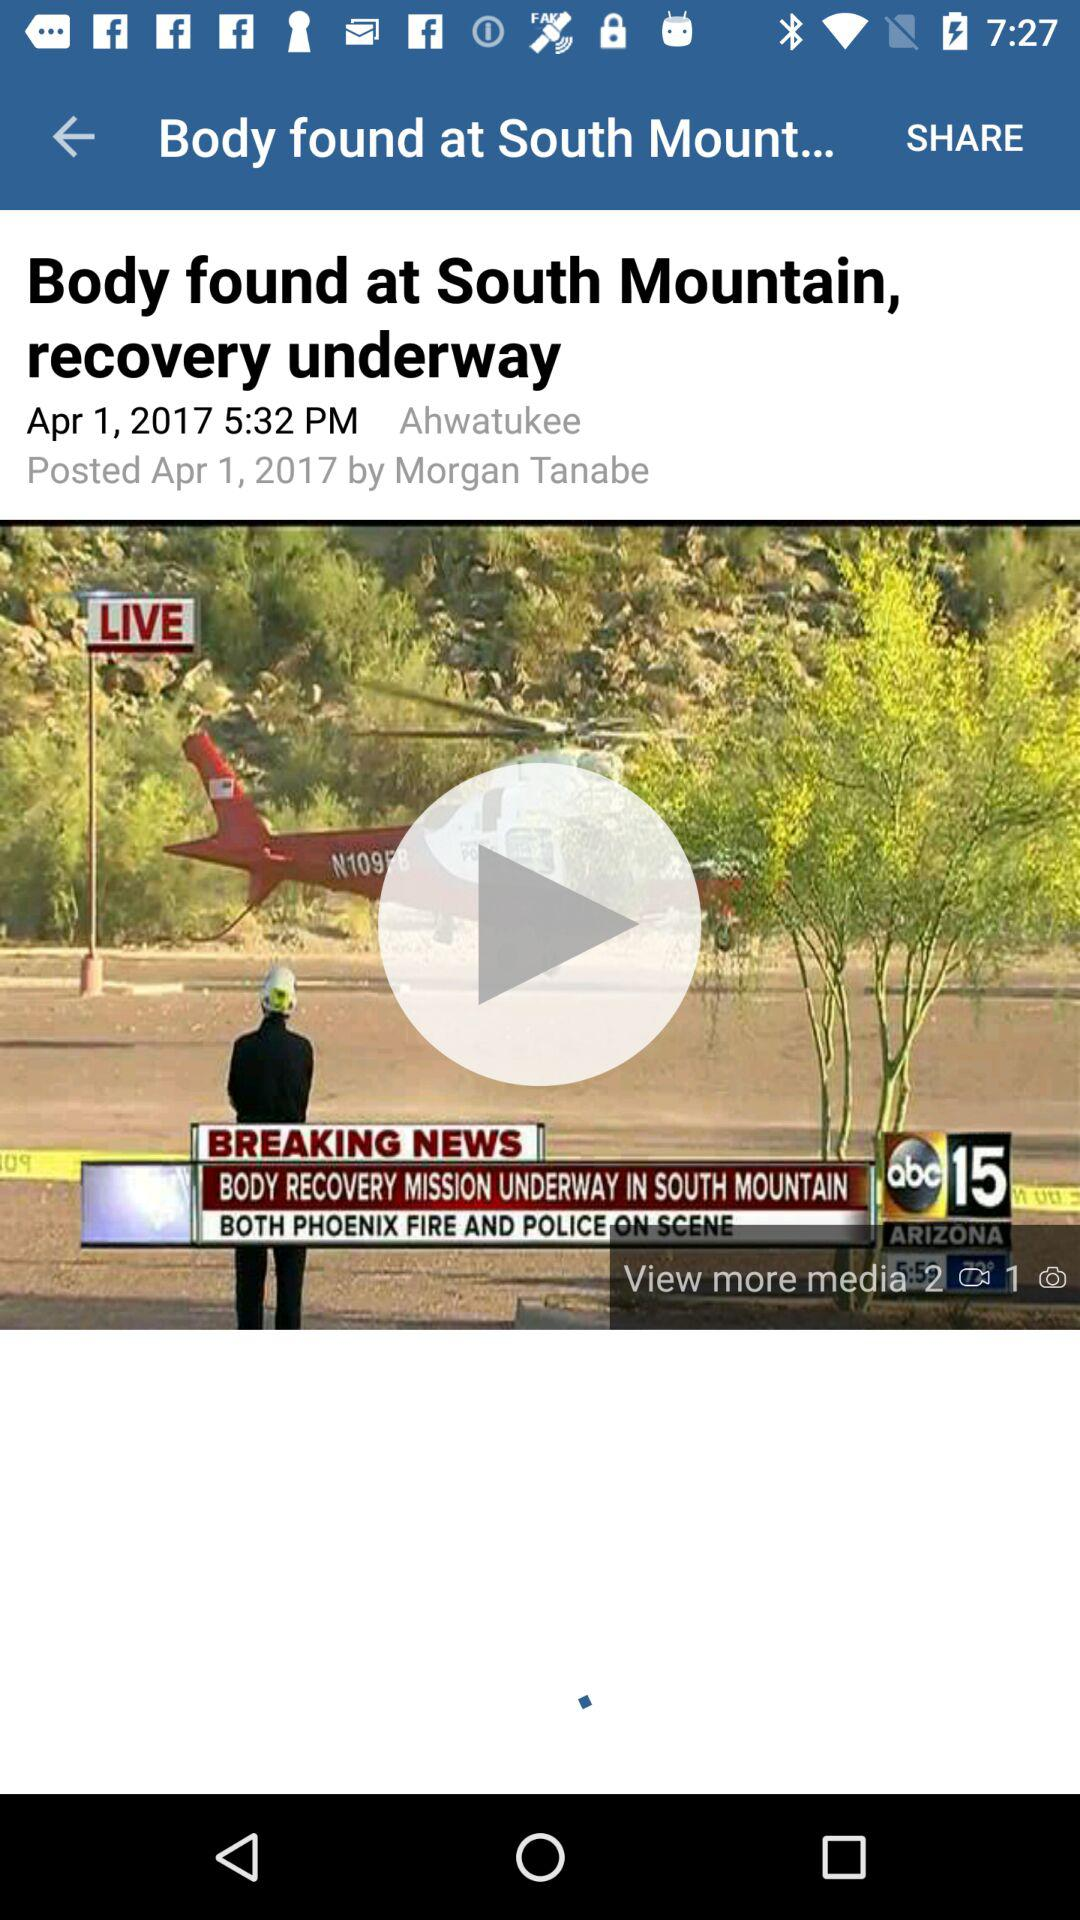Who posted the news? The news was posted by Morgan Tanabe. 